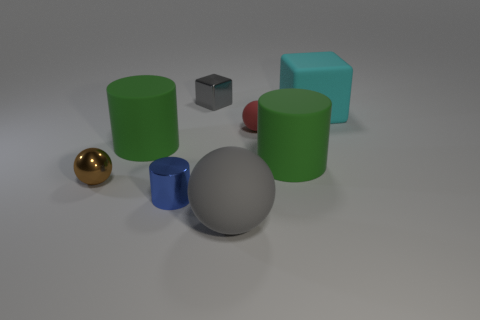Add 1 purple cylinders. How many objects exist? 9 Subtract all green matte cylinders. How many cylinders are left? 1 Subtract 1 cylinders. How many cylinders are left? 2 Subtract all brown blocks. How many green cylinders are left? 2 Subtract all cyan cubes. Subtract all red objects. How many objects are left? 6 Add 2 brown spheres. How many brown spheres are left? 3 Add 2 large spheres. How many large spheres exist? 3 Subtract all gray balls. How many balls are left? 2 Subtract 1 blue cylinders. How many objects are left? 7 Subtract all blocks. How many objects are left? 6 